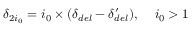<formula> <loc_0><loc_0><loc_500><loc_500>\delta _ { 2 i _ { 0 } } = i _ { 0 } \times ( \delta _ { d e l } - \delta _ { d e l } ^ { \prime } ) , \, \ i _ { 0 } > 1</formula> 